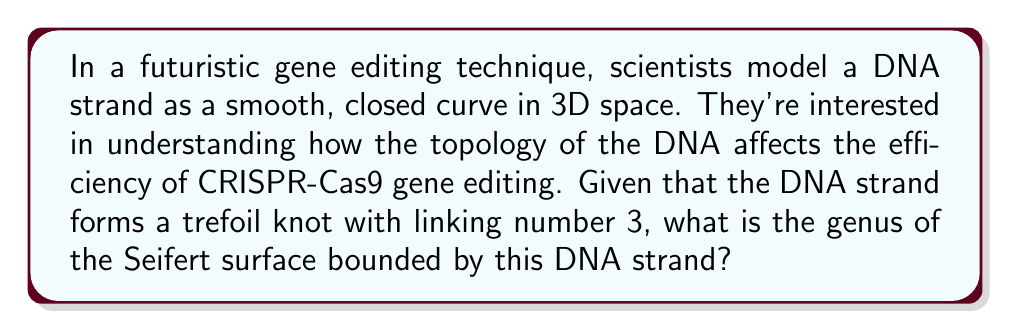Can you answer this question? To solve this problem, we need to understand several concepts from knot theory and manifold topology:

1. Trefoil knot: This is the simplest non-trivial knot, with a crossing number of 3.

2. Linking number: For a knot, the linking number is equal to half the sum of the signed crossings in any diagram of the knot.

3. Seifert surface: This is an orientable surface whose boundary is the given knot.

4. Genus: The genus of a surface is the number of handles attached to a sphere to obtain that surface.

Now, let's use the Seifert algorithm to construct a surface and calculate its genus:

1. The trefoil knot has 3 crossings. At each crossing, we replace the crossing with a small bridge, creating three disconnected circles.

2. We then fill these circles with disks, which will form the base of our Seifert surface.

3. The number of disks (Seifert circles) is denoted as $s$, which in this case is 3.

4. The number of half-twists (equal to the number of original crossings) is denoted as $c$, which is also 3.

5. The Euler characteristic $\chi$ of the Seifert surface is given by:

   $$\chi = s - c = 3 - 3 = 0$$

6. The relationship between Euler characteristic, genus $g$, and number of boundary components $b$ for an orientable surface is:

   $$\chi = 2 - 2g - b$$

7. In our case, $b = 1$ (single boundary component), so:

   $$0 = 2 - 2g - 1$$
   $$2g = 1$$
   $$g = \frac{1}{2}$$

Therefore, the genus of the Seifert surface bounded by this DNA strand is 1/2.

This result aligns with the known fact that the minimal genus of a Seifert surface for a trefoil knot is indeed 1/2.
Answer: The genus of the Seifert surface bounded by the DNA strand is $\frac{1}{2}$. 